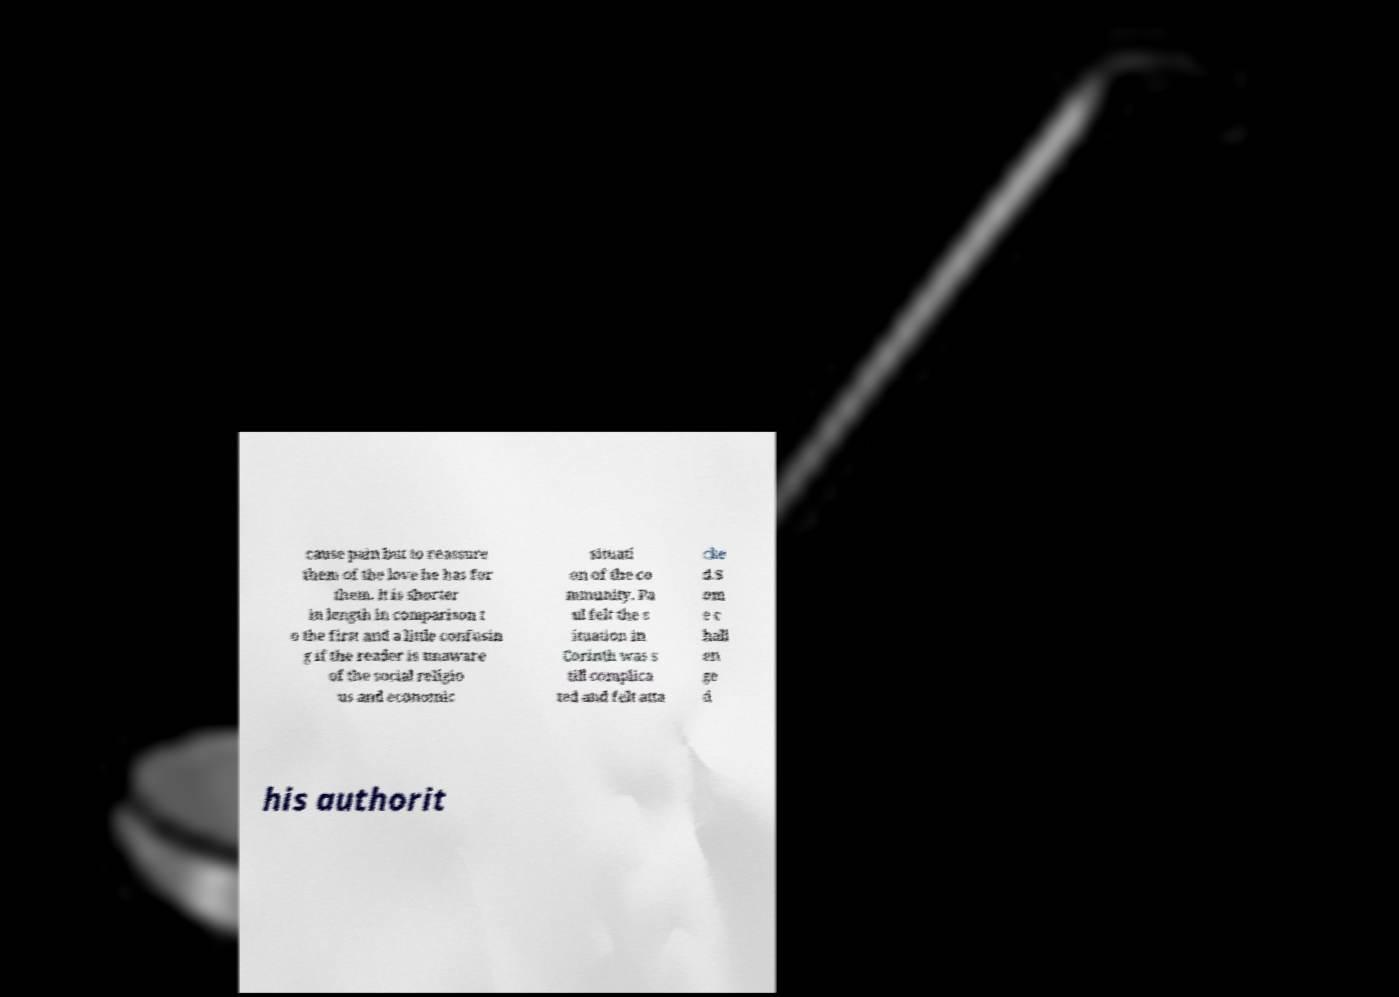There's text embedded in this image that I need extracted. Can you transcribe it verbatim? cause pain but to reassure them of the love he has for them. It is shorter in length in comparison t o the first and a little confusin g if the reader is unaware of the social religio us and economic situati on of the co mmunity. Pa ul felt the s ituation in Corinth was s till complica ted and felt atta cke d.S om e c hall en ge d his authorit 